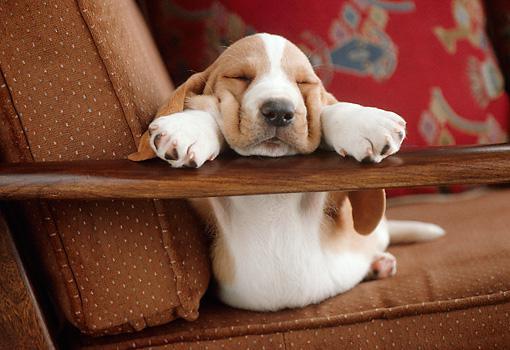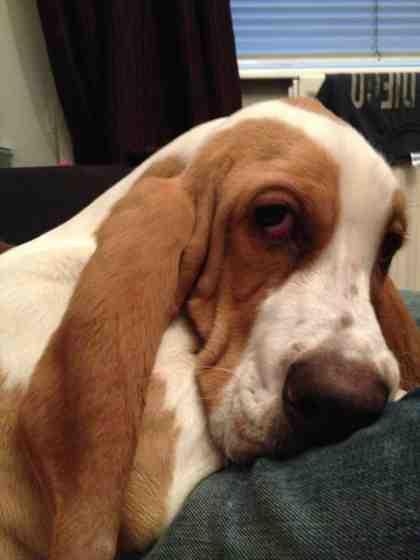The first image is the image on the left, the second image is the image on the right. Analyze the images presented: Is the assertion "One dog has its eyes open." valid? Answer yes or no. Yes. The first image is the image on the left, the second image is the image on the right. Analyze the images presented: Is the assertion "One of the images has a dog laying on a log." valid? Answer yes or no. No. 